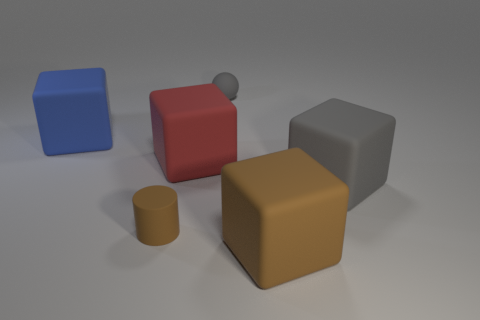Add 1 small gray spheres. How many objects exist? 7 Subtract all balls. How many objects are left? 5 Subtract all blue rubber objects. Subtract all small green shiny things. How many objects are left? 5 Add 1 big matte cubes. How many big matte cubes are left? 5 Add 4 tiny brown things. How many tiny brown things exist? 5 Subtract 0 yellow blocks. How many objects are left? 6 